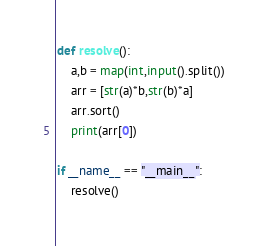<code> <loc_0><loc_0><loc_500><loc_500><_Python_>def resolve():
    a,b = map(int,input().split())
    arr = [str(a)*b,str(b)*a]
    arr.sort()
    print(arr[0])

if __name__ == "__main__":
    resolve()</code> 